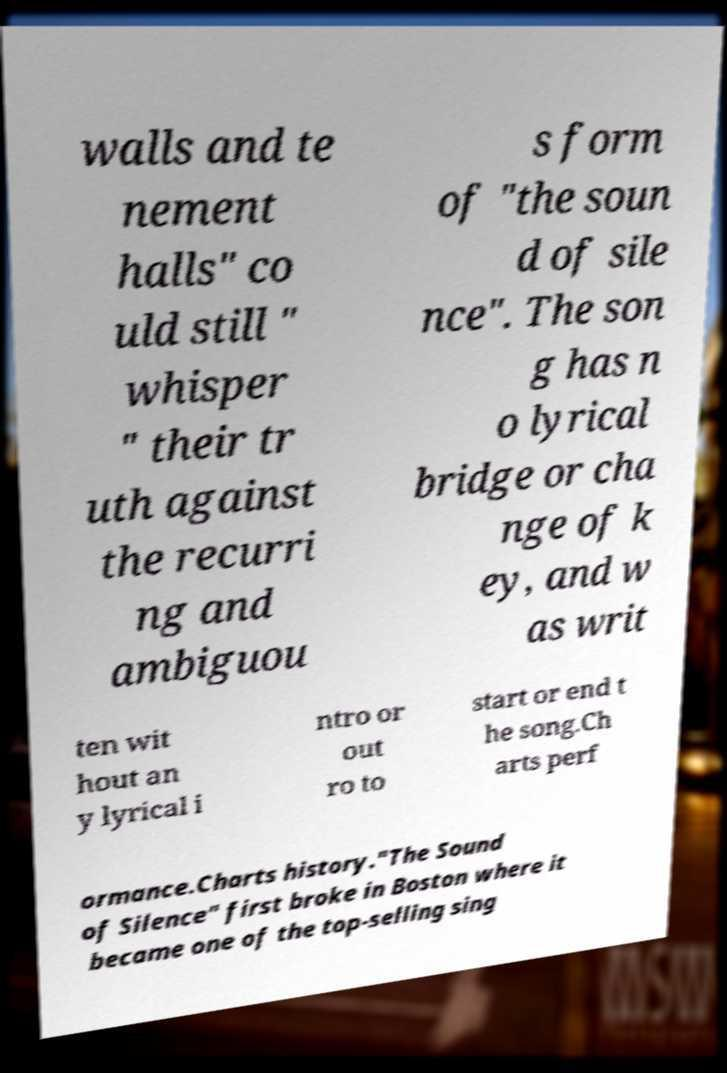Could you extract and type out the text from this image? walls and te nement halls" co uld still " whisper " their tr uth against the recurri ng and ambiguou s form of "the soun d of sile nce". The son g has n o lyrical bridge or cha nge of k ey, and w as writ ten wit hout an y lyrical i ntro or out ro to start or end t he song.Ch arts perf ormance.Charts history."The Sound of Silence" first broke in Boston where it became one of the top-selling sing 